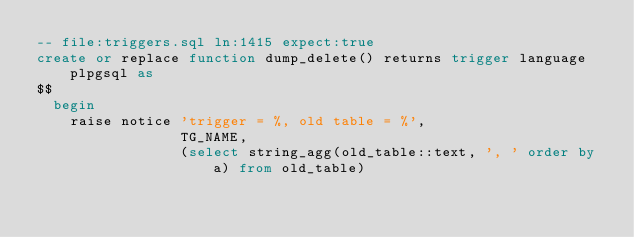<code> <loc_0><loc_0><loc_500><loc_500><_SQL_>-- file:triggers.sql ln:1415 expect:true
create or replace function dump_delete() returns trigger language plpgsql as
$$
  begin
    raise notice 'trigger = %, old table = %',
                 TG_NAME,
                 (select string_agg(old_table::text, ', ' order by a) from old_table)
</code> 